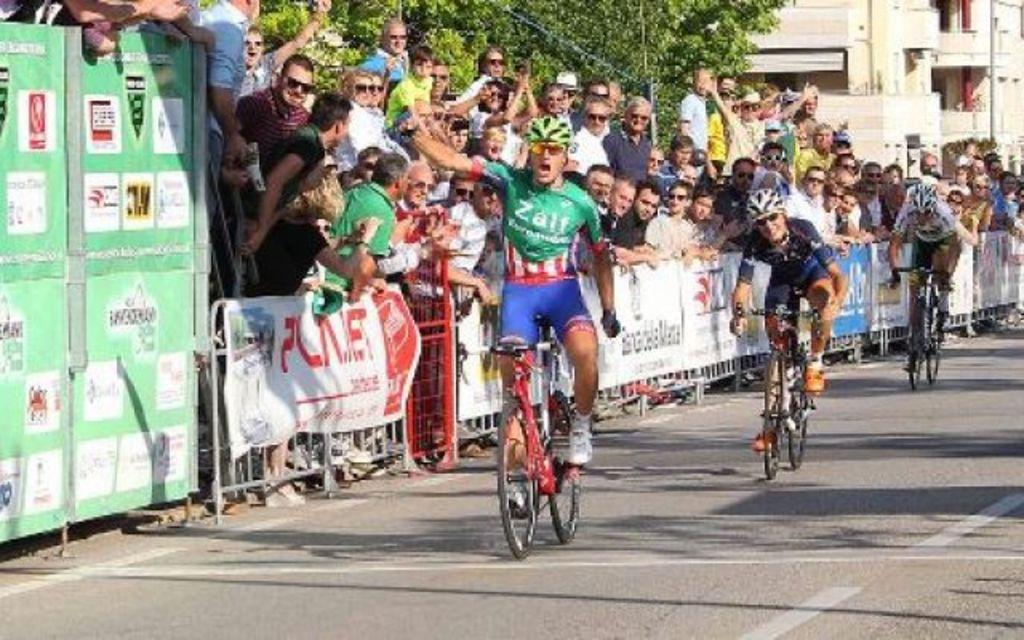<image>
Create a compact narrative representing the image presented. A group of cyclists on a road with people on the side behind a barrier cheering them on as the man in green wears a cyclist uniform that says Zalf. 